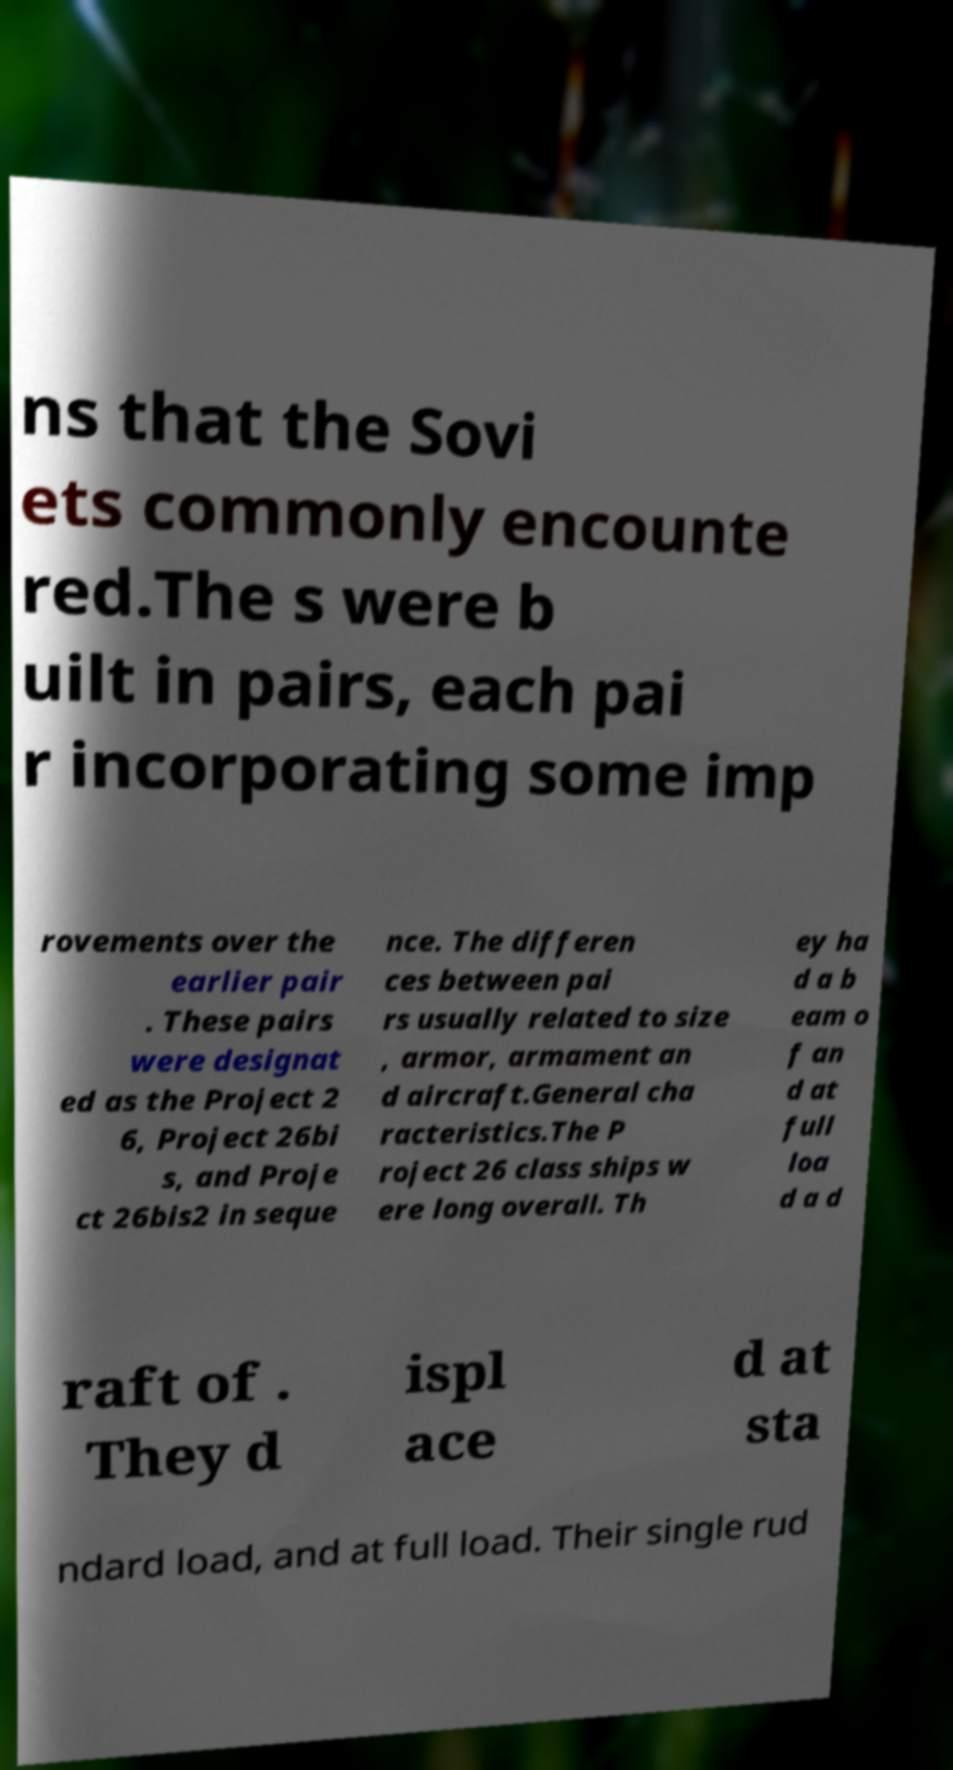There's text embedded in this image that I need extracted. Can you transcribe it verbatim? ns that the Sovi ets commonly encounte red.The s were b uilt in pairs, each pai r incorporating some imp rovements over the earlier pair . These pairs were designat ed as the Project 2 6, Project 26bi s, and Proje ct 26bis2 in seque nce. The differen ces between pai rs usually related to size , armor, armament an d aircraft.General cha racteristics.The P roject 26 class ships w ere long overall. Th ey ha d a b eam o f an d at full loa d a d raft of . They d ispl ace d at sta ndard load, and at full load. Their single rud 